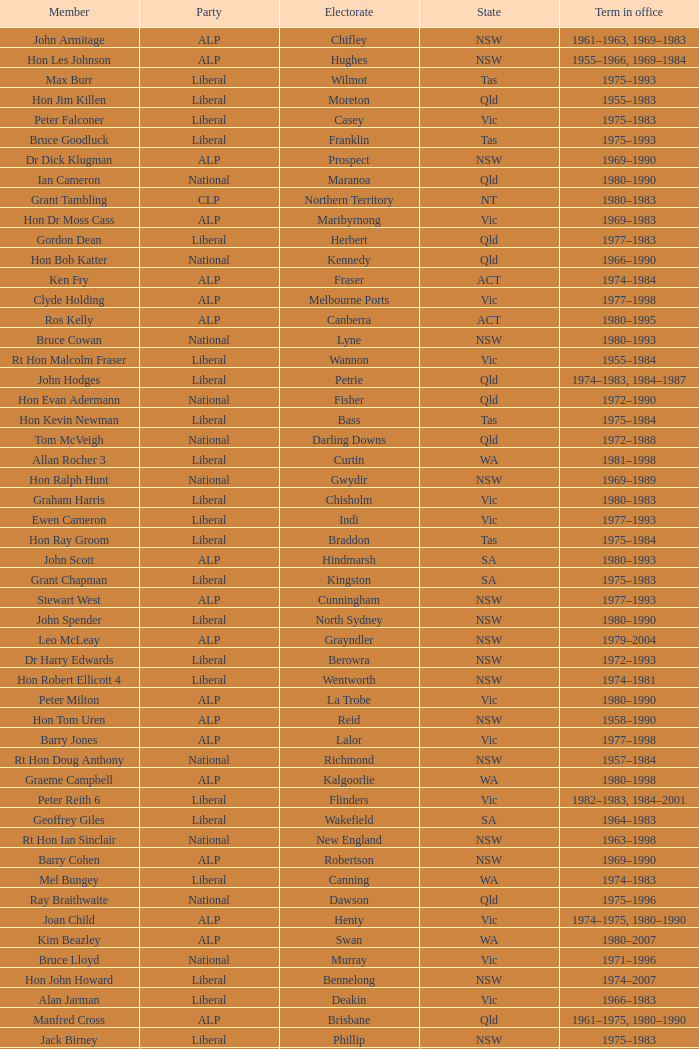To what party does Ralph Jacobi belong? ALP. 